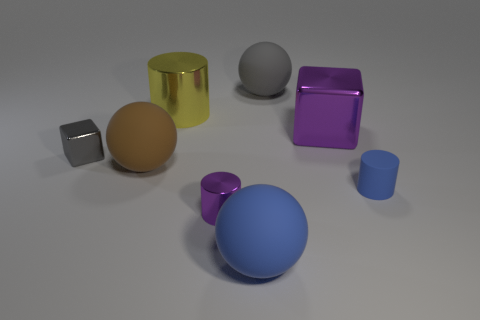Subtract all big cylinders. How many cylinders are left? 2 Add 2 purple cylinders. How many objects exist? 10 Subtract all brown spheres. How many spheres are left? 2 Subtract all blocks. How many objects are left? 6 Subtract 3 cylinders. How many cylinders are left? 0 Add 6 metallic cubes. How many metallic cubes exist? 8 Subtract 0 brown cylinders. How many objects are left? 8 Subtract all purple spheres. Subtract all yellow cylinders. How many spheres are left? 3 Subtract all metal objects. Subtract all large shiny cubes. How many objects are left? 3 Add 8 tiny gray cubes. How many tiny gray cubes are left? 9 